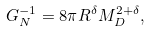Convert formula to latex. <formula><loc_0><loc_0><loc_500><loc_500>G ^ { - 1 } _ { N } = 8 \pi R ^ { \delta } M ^ { 2 + \delta } _ { D } ,</formula> 